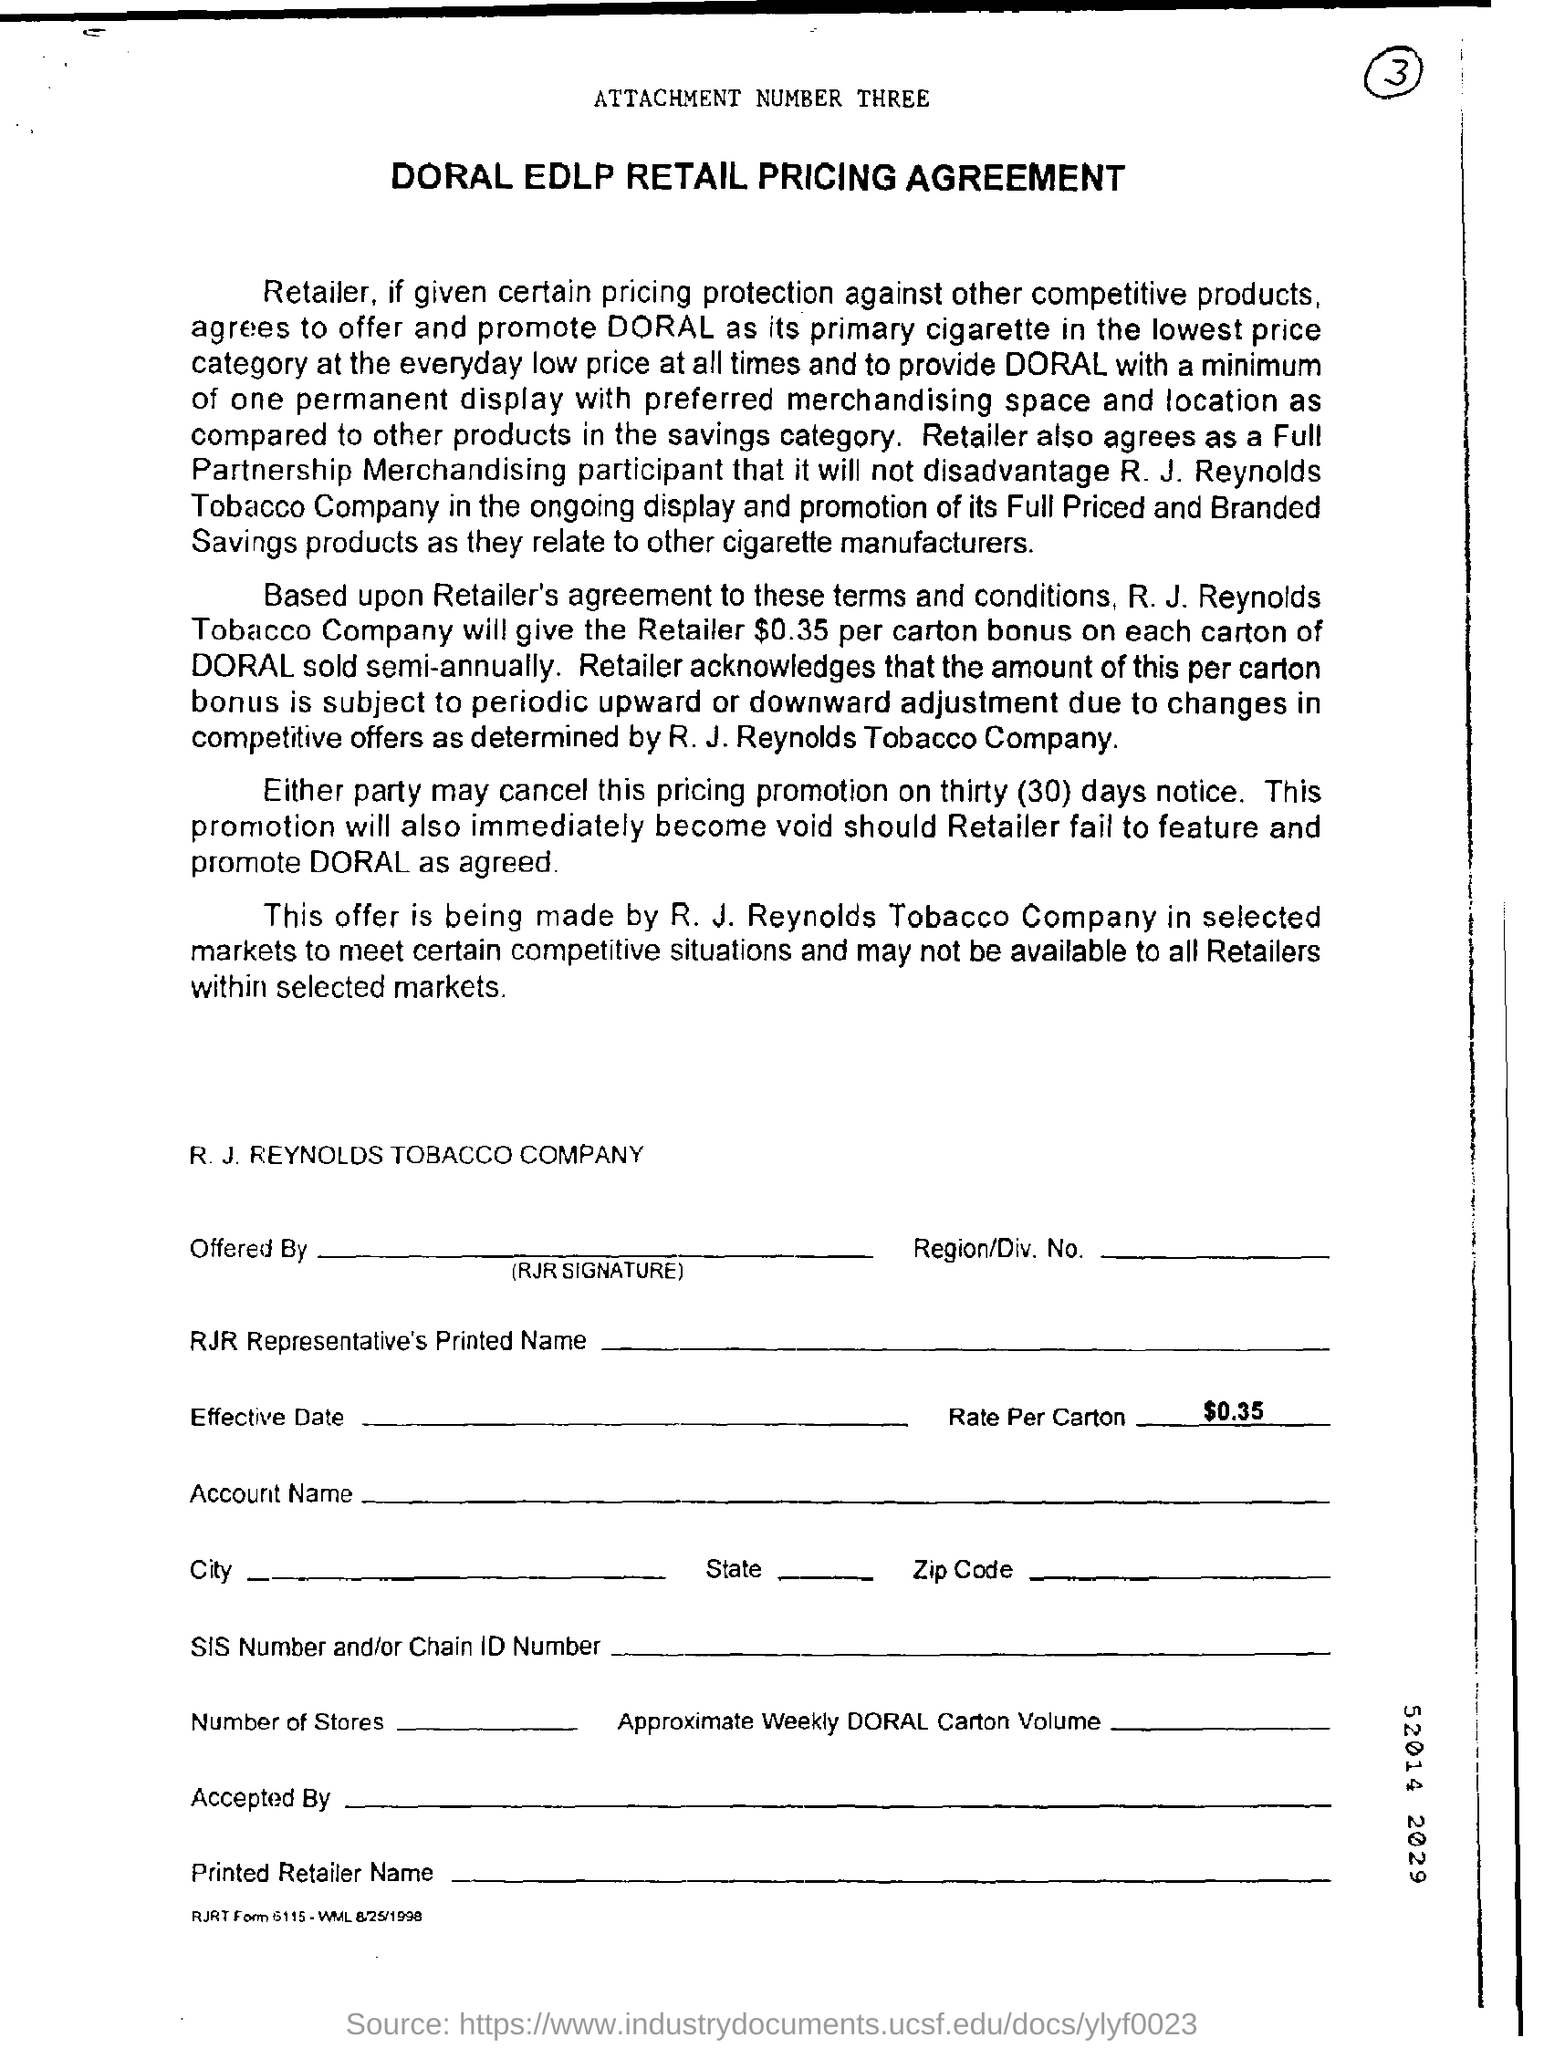What agreement is shown here?
Ensure brevity in your answer.  DORAL EDLP RETAIL PRICING AGREEMENT. What is the name of the company?
Your answer should be very brief. R. J. REYNOLDS TOBACCO COMPANY. 